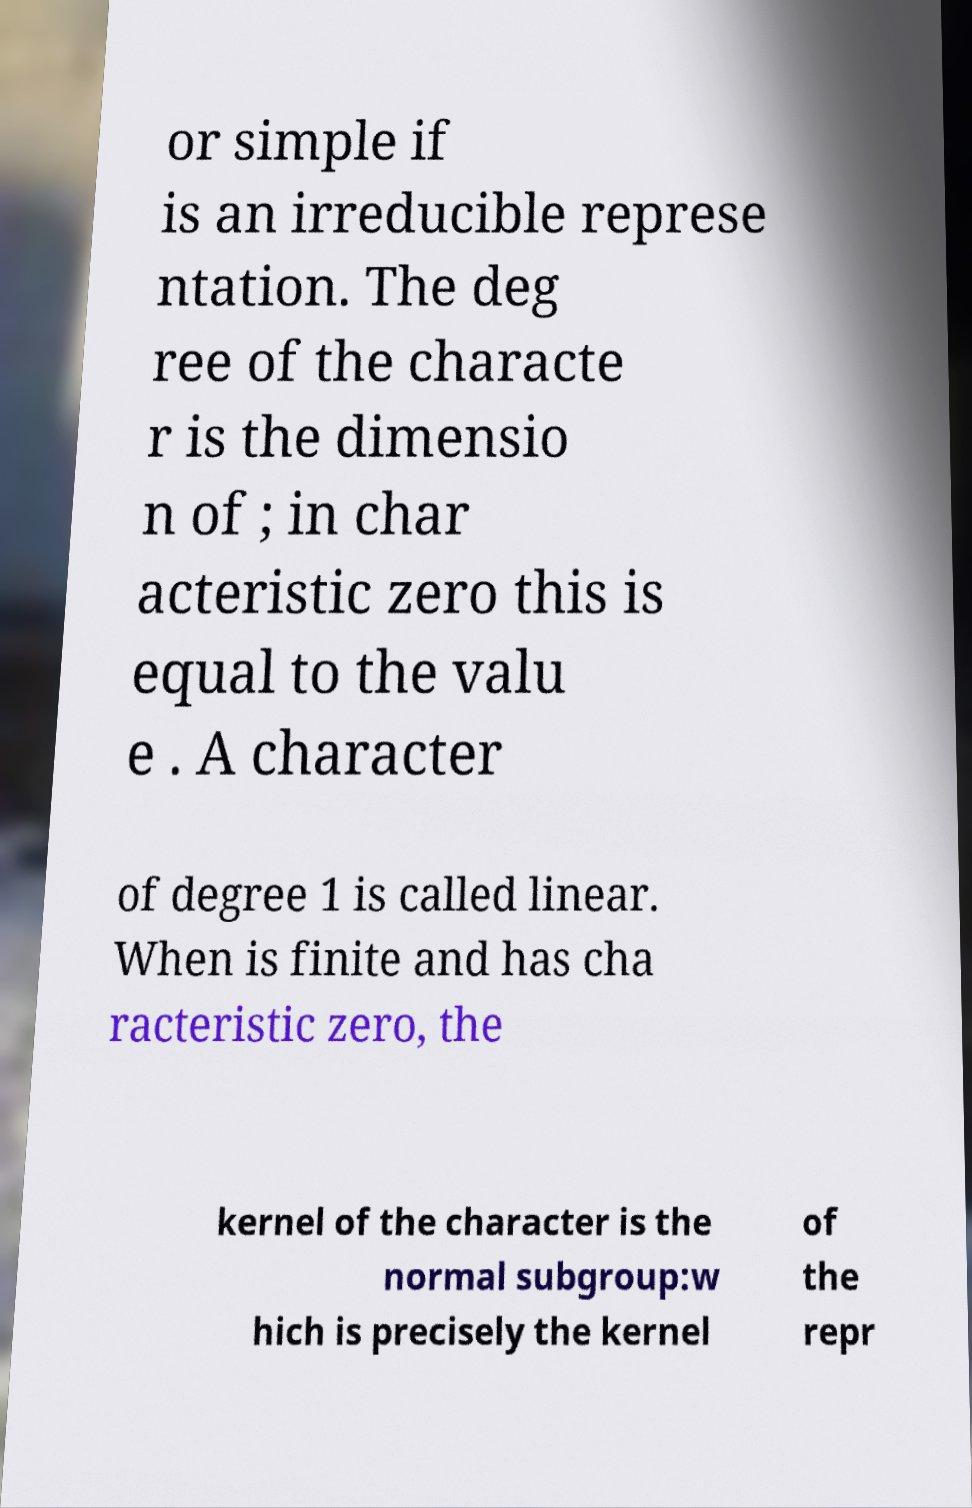Please identify and transcribe the text found in this image. or simple if is an irreducible represe ntation. The deg ree of the characte r is the dimensio n of ; in char acteristic zero this is equal to the valu e . A character of degree 1 is called linear. When is finite and has cha racteristic zero, the kernel of the character is the normal subgroup:w hich is precisely the kernel of the repr 